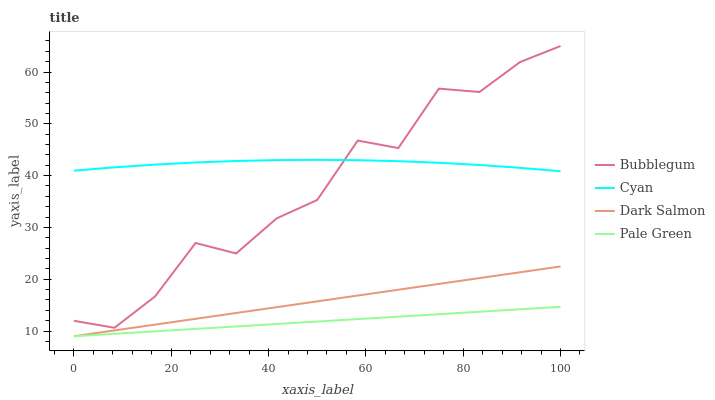Does Pale Green have the minimum area under the curve?
Answer yes or no. Yes. Does Cyan have the maximum area under the curve?
Answer yes or no. Yes. Does Dark Salmon have the minimum area under the curve?
Answer yes or no. No. Does Dark Salmon have the maximum area under the curve?
Answer yes or no. No. Is Dark Salmon the smoothest?
Answer yes or no. Yes. Is Bubblegum the roughest?
Answer yes or no. Yes. Is Pale Green the smoothest?
Answer yes or no. No. Is Pale Green the roughest?
Answer yes or no. No. Does Bubblegum have the lowest value?
Answer yes or no. No. Does Bubblegum have the highest value?
Answer yes or no. Yes. Does Dark Salmon have the highest value?
Answer yes or no. No. Is Dark Salmon less than Bubblegum?
Answer yes or no. Yes. Is Cyan greater than Pale Green?
Answer yes or no. Yes. Does Dark Salmon intersect Pale Green?
Answer yes or no. Yes. Is Dark Salmon less than Pale Green?
Answer yes or no. No. Is Dark Salmon greater than Pale Green?
Answer yes or no. No. Does Dark Salmon intersect Bubblegum?
Answer yes or no. No. 